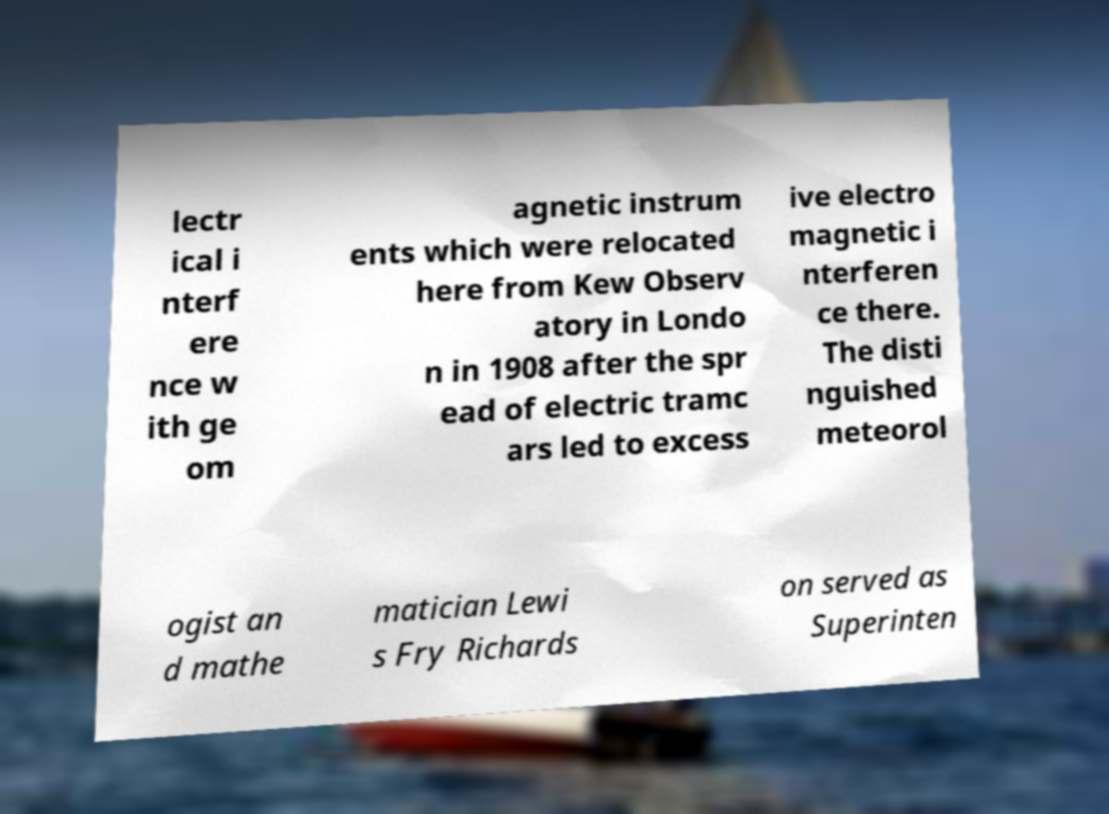Can you accurately transcribe the text from the provided image for me? lectr ical i nterf ere nce w ith ge om agnetic instrum ents which were relocated here from Kew Observ atory in Londo n in 1908 after the spr ead of electric tramc ars led to excess ive electro magnetic i nterferen ce there. The disti nguished meteorol ogist an d mathe matician Lewi s Fry Richards on served as Superinten 